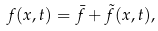Convert formula to latex. <formula><loc_0><loc_0><loc_500><loc_500>f ( x , t ) = \bar { f } + \tilde { f } ( x , t ) ,</formula> 